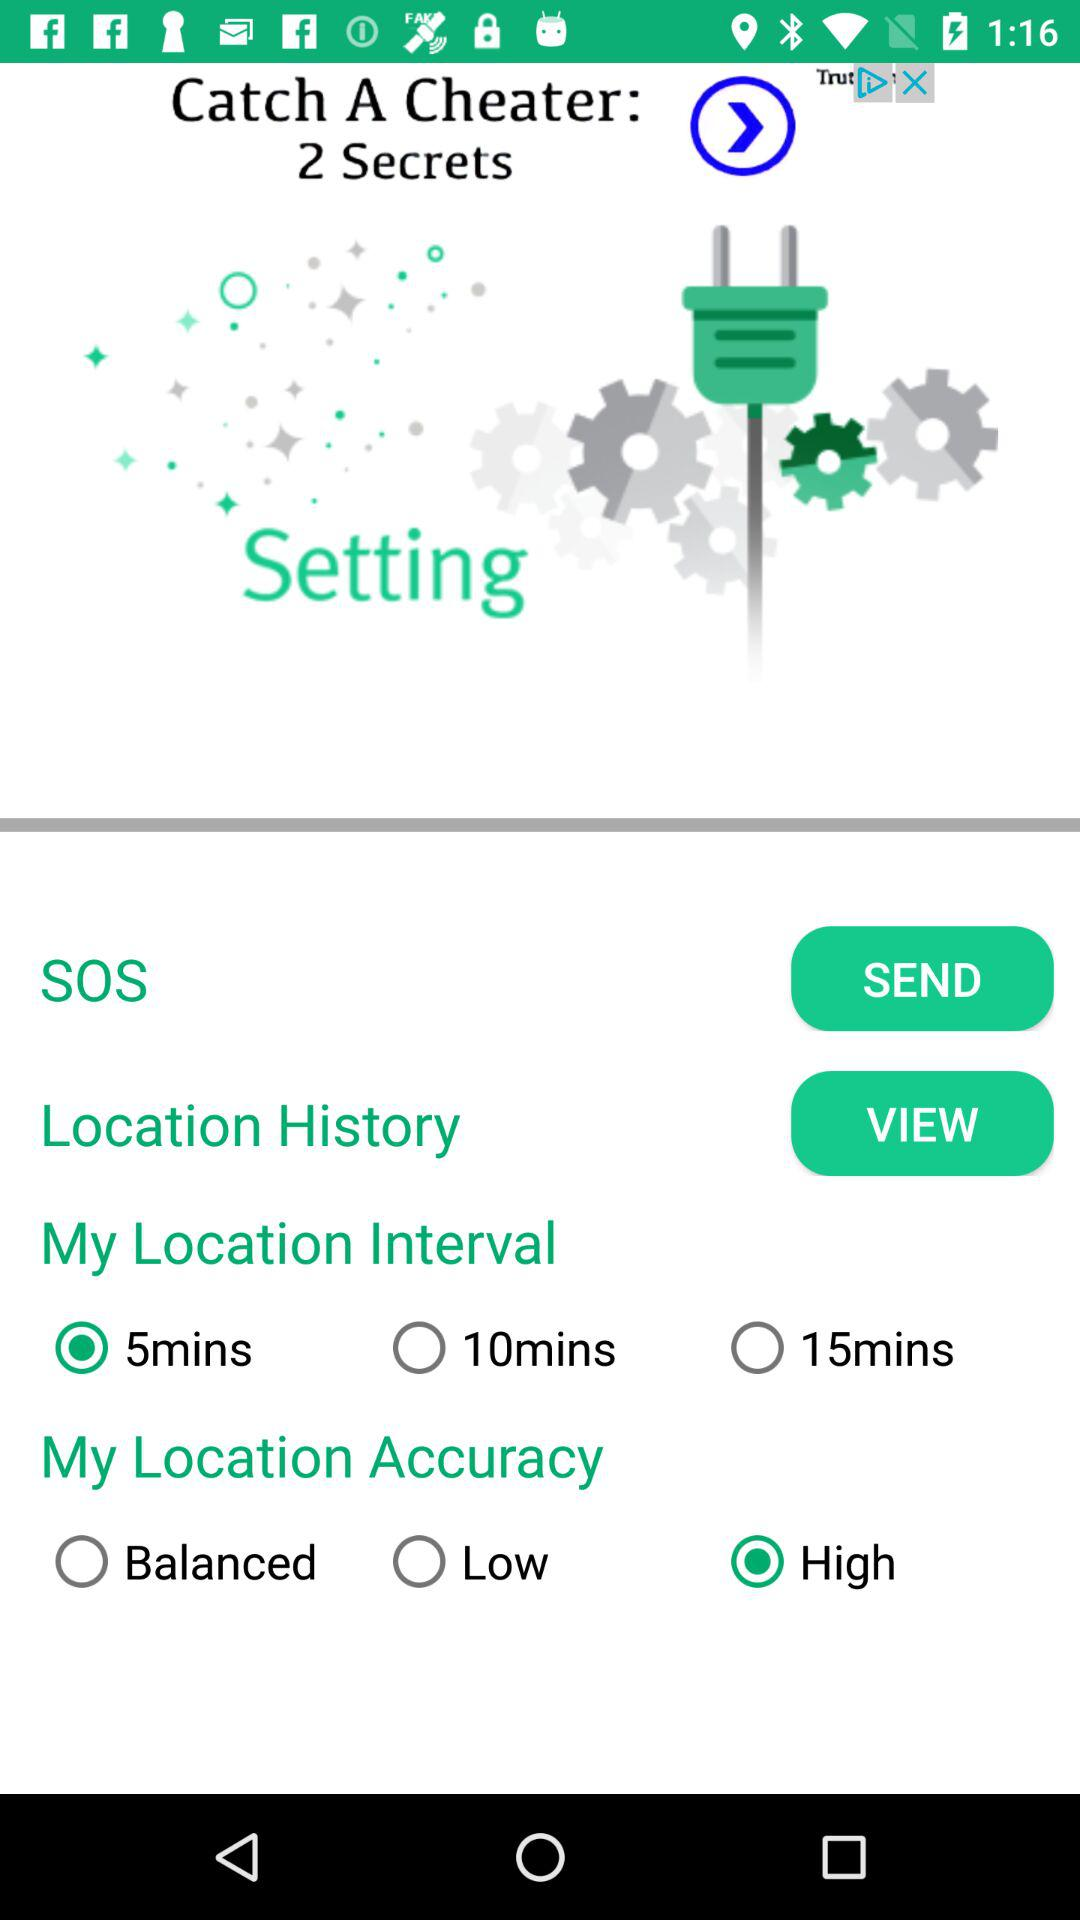What are the different location intervals? The different location intervals are 5 minutes, 10 minutes and 15 minutes. 